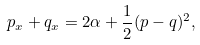Convert formula to latex. <formula><loc_0><loc_0><loc_500><loc_500>p _ { x } + q _ { x } = 2 \alpha + \frac { 1 } { 2 } ( p - q ) ^ { 2 } ,</formula> 